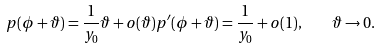<formula> <loc_0><loc_0><loc_500><loc_500>p ( \phi + \vartheta ) = \frac { 1 } { y _ { 0 } } \vartheta + o ( \vartheta ) p ^ { \prime } ( \phi + \vartheta ) = \frac { 1 } { y _ { 0 } } + o ( 1 ) , \quad \vartheta \to 0 .</formula> 